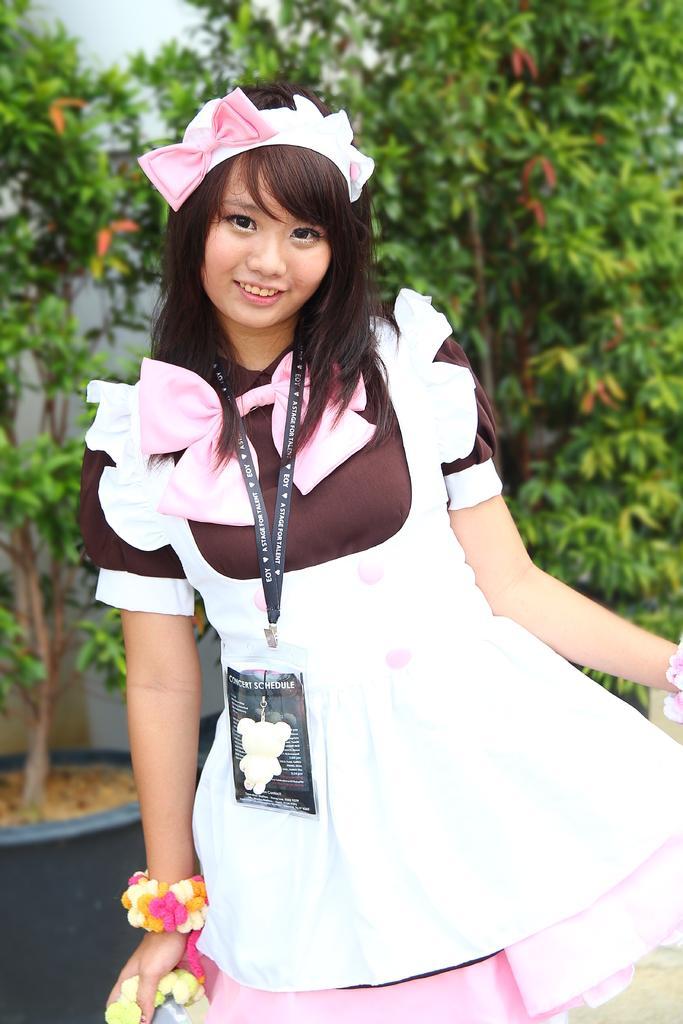Can you describe this image briefly? Here we can see a girl standing and there is a ID card on her neck and she is holding an object in her hand. In the background we can see plants and wall. 